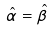<formula> <loc_0><loc_0><loc_500><loc_500>\hat { \alpha } = \hat { \beta }</formula> 